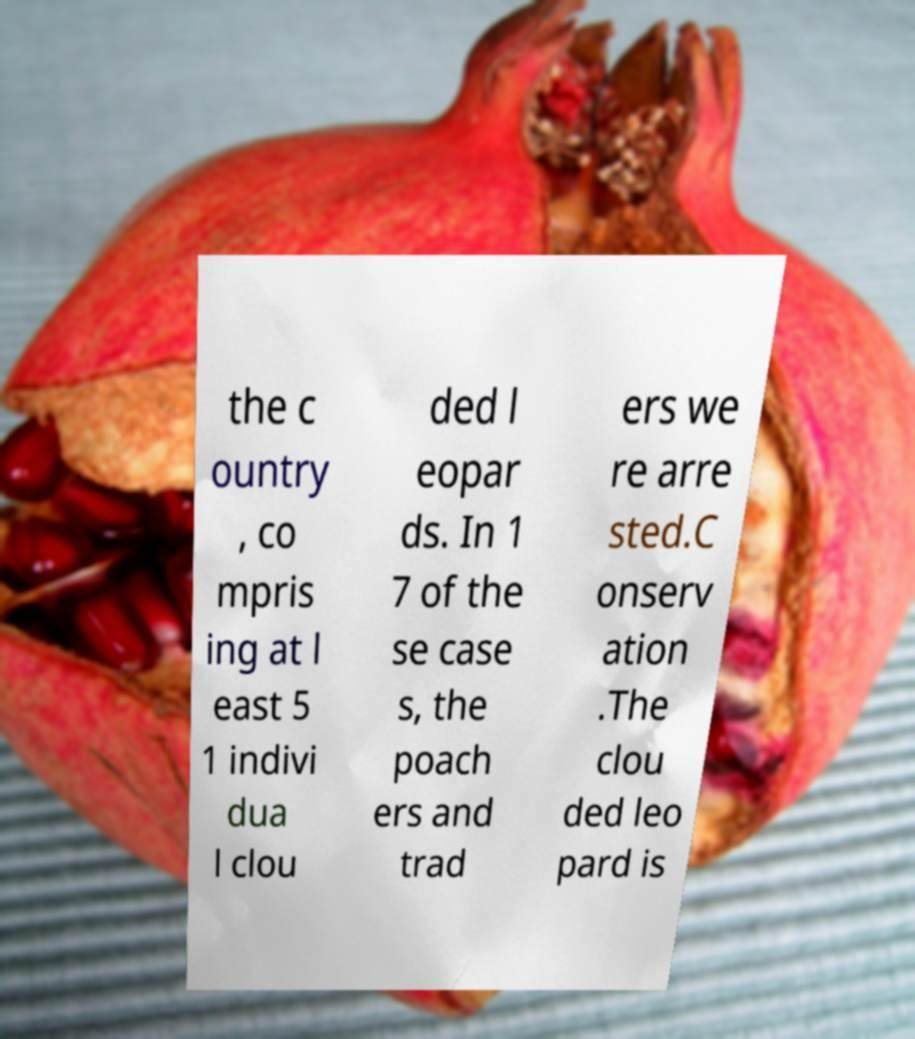Could you extract and type out the text from this image? the c ountry , co mpris ing at l east 5 1 indivi dua l clou ded l eopar ds. In 1 7 of the se case s, the poach ers and trad ers we re arre sted.C onserv ation .The clou ded leo pard is 